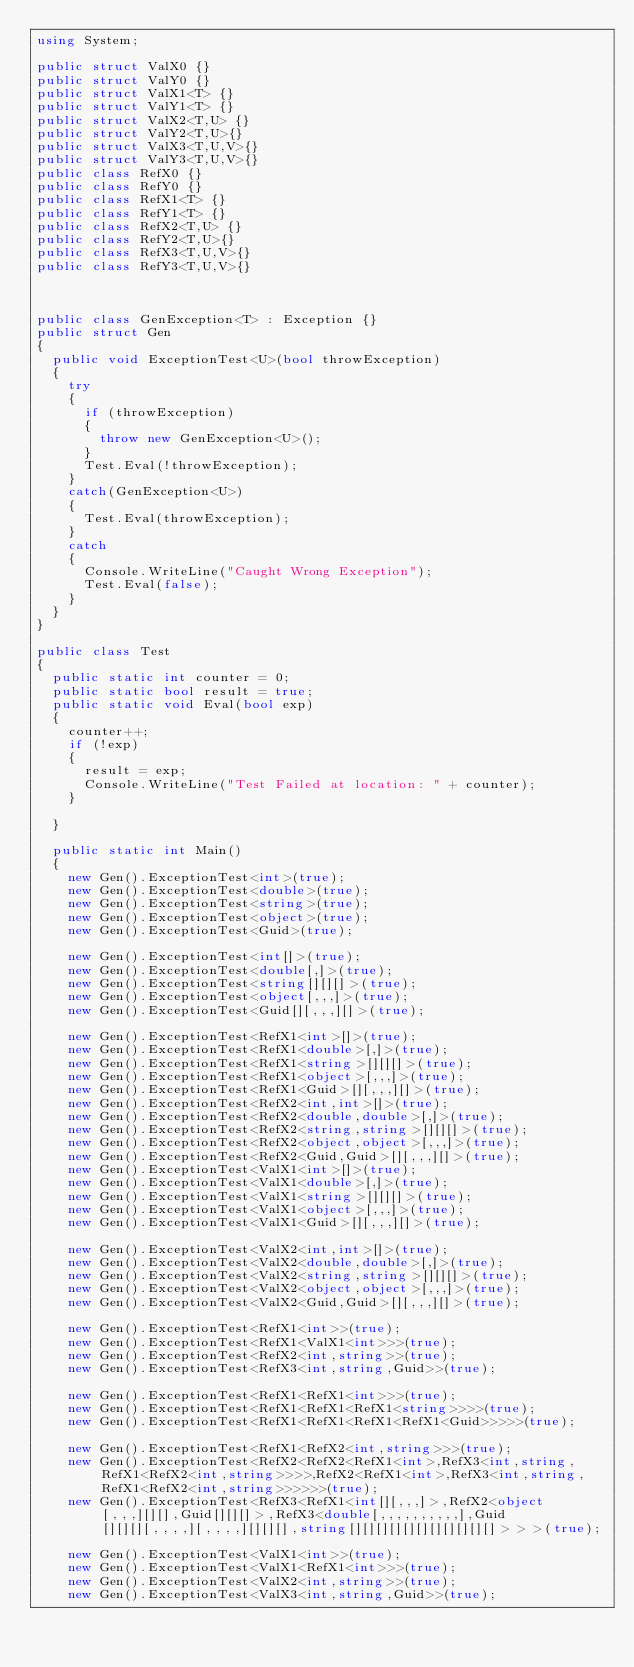Convert code to text. <code><loc_0><loc_0><loc_500><loc_500><_C#_>using System;

public struct ValX0 {}
public struct ValY0 {}
public struct ValX1<T> {}
public struct ValY1<T> {}
public struct ValX2<T,U> {}
public struct ValY2<T,U>{}
public struct ValX3<T,U,V>{}
public struct ValY3<T,U,V>{}
public class RefX0 {}
public class RefY0 {}
public class RefX1<T> {}
public class RefY1<T> {}
public class RefX2<T,U> {}
public class RefY2<T,U>{}
public class RefX3<T,U,V>{}
public class RefY3<T,U,V>{}



public class GenException<T> : Exception {}
public struct Gen
{
	public void ExceptionTest<U>(bool throwException)
	{
		try
		{
			if (throwException)
			{
				throw new GenException<U>();
			}
			Test.Eval(!throwException);
		}
		catch(GenException<U>)
		{
			Test.Eval(throwException);
		}
		catch
		{
			Console.WriteLine("Caught Wrong Exception");
			Test.Eval(false);
		}
	}
}

public class Test
{
	public static int counter = 0;
	public static bool result = true;
	public static void Eval(bool exp)
	{
		counter++;
		if (!exp)
		{
			result = exp;
			Console.WriteLine("Test Failed at location: " + counter);
		}
	
	}
	
	public static int Main()
	{
		new Gen().ExceptionTest<int>(true);
		new Gen().ExceptionTest<double>(true); 
		new Gen().ExceptionTest<string>(true);
		new Gen().ExceptionTest<object>(true); 
		new Gen().ExceptionTest<Guid>(true); 

		new Gen().ExceptionTest<int[]>(true); 
		new Gen().ExceptionTest<double[,]>(true); 
		new Gen().ExceptionTest<string[][][]>(true); 
		new Gen().ExceptionTest<object[,,,]>(true); 
		new Gen().ExceptionTest<Guid[][,,,][]>(true); 

		new Gen().ExceptionTest<RefX1<int>[]>(true); 
		new Gen().ExceptionTest<RefX1<double>[,]>(true); 
		new Gen().ExceptionTest<RefX1<string>[][][]>(true); 
		new Gen().ExceptionTest<RefX1<object>[,,,]>(true); 
		new Gen().ExceptionTest<RefX1<Guid>[][,,,][]>(true); 
		new Gen().ExceptionTest<RefX2<int,int>[]>(true); 
		new Gen().ExceptionTest<RefX2<double,double>[,]>(true); 
		new Gen().ExceptionTest<RefX2<string,string>[][][]>(true); 
		new Gen().ExceptionTest<RefX2<object,object>[,,,]>(true); 
		new Gen().ExceptionTest<RefX2<Guid,Guid>[][,,,][]>(true); 
		new Gen().ExceptionTest<ValX1<int>[]>(true); 
		new Gen().ExceptionTest<ValX1<double>[,]>(true); 
		new Gen().ExceptionTest<ValX1<string>[][][]>(true); 
		new Gen().ExceptionTest<ValX1<object>[,,,]>(true); 
		new Gen().ExceptionTest<ValX1<Guid>[][,,,][]>(true); 

		new Gen().ExceptionTest<ValX2<int,int>[]>(true); 
		new Gen().ExceptionTest<ValX2<double,double>[,]>(true); 
		new Gen().ExceptionTest<ValX2<string,string>[][][]>(true); 
		new Gen().ExceptionTest<ValX2<object,object>[,,,]>(true); 
		new Gen().ExceptionTest<ValX2<Guid,Guid>[][,,,][]>(true); 
		
		new Gen().ExceptionTest<RefX1<int>>(true); 
		new Gen().ExceptionTest<RefX1<ValX1<int>>>(true); 
		new Gen().ExceptionTest<RefX2<int,string>>(true); 
		new Gen().ExceptionTest<RefX3<int,string,Guid>>(true); 

		new Gen().ExceptionTest<RefX1<RefX1<int>>>(true); 
		new Gen().ExceptionTest<RefX1<RefX1<RefX1<string>>>>(true); 
		new Gen().ExceptionTest<RefX1<RefX1<RefX1<RefX1<Guid>>>>>(true); 

		new Gen().ExceptionTest<RefX1<RefX2<int,string>>>(true); 
		new Gen().ExceptionTest<RefX2<RefX2<RefX1<int>,RefX3<int,string, RefX1<RefX2<int,string>>>>,RefX2<RefX1<int>,RefX3<int,string, RefX1<RefX2<int,string>>>>>>(true); 
		new Gen().ExceptionTest<RefX3<RefX1<int[][,,,]>,RefX2<object[,,,][][],Guid[][][]>,RefX3<double[,,,,,,,,,,],Guid[][][][,,,,][,,,,][][][],string[][][][][][][][][][][]>>>(true); 

		new Gen().ExceptionTest<ValX1<int>>(true); 
		new Gen().ExceptionTest<ValX1<RefX1<int>>>(true); 
		new Gen().ExceptionTest<ValX2<int,string>>(true); 
		new Gen().ExceptionTest<ValX3<int,string,Guid>>(true); 
</code> 